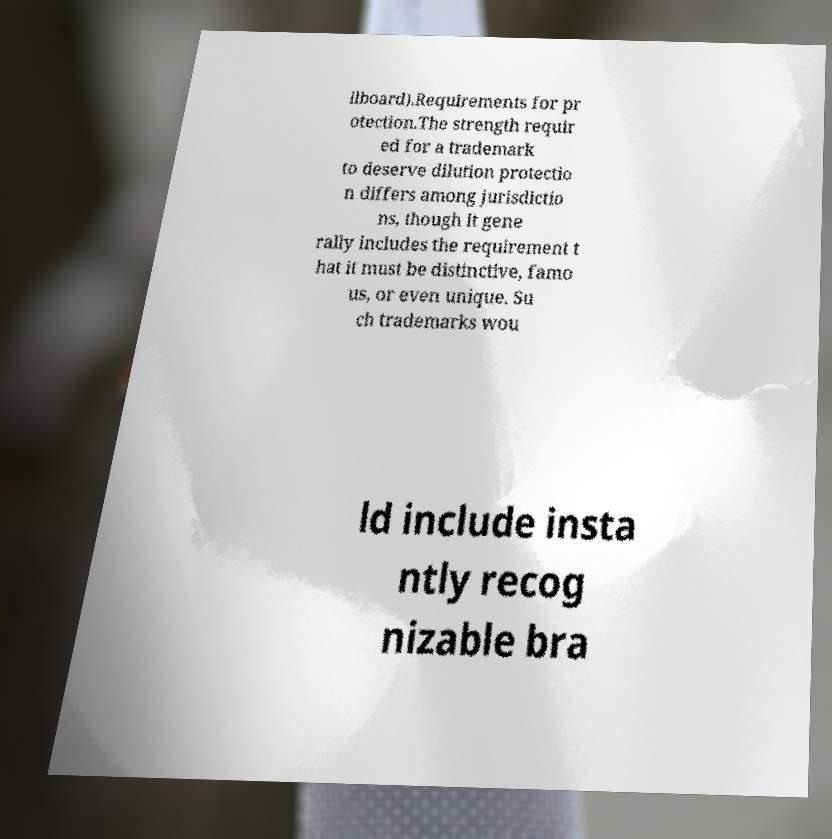Could you assist in decoding the text presented in this image and type it out clearly? llboard).Requirements for pr otection.The strength requir ed for a trademark to deserve dilution protectio n differs among jurisdictio ns, though it gene rally includes the requirement t hat it must be distinctive, famo us, or even unique. Su ch trademarks wou ld include insta ntly recog nizable bra 